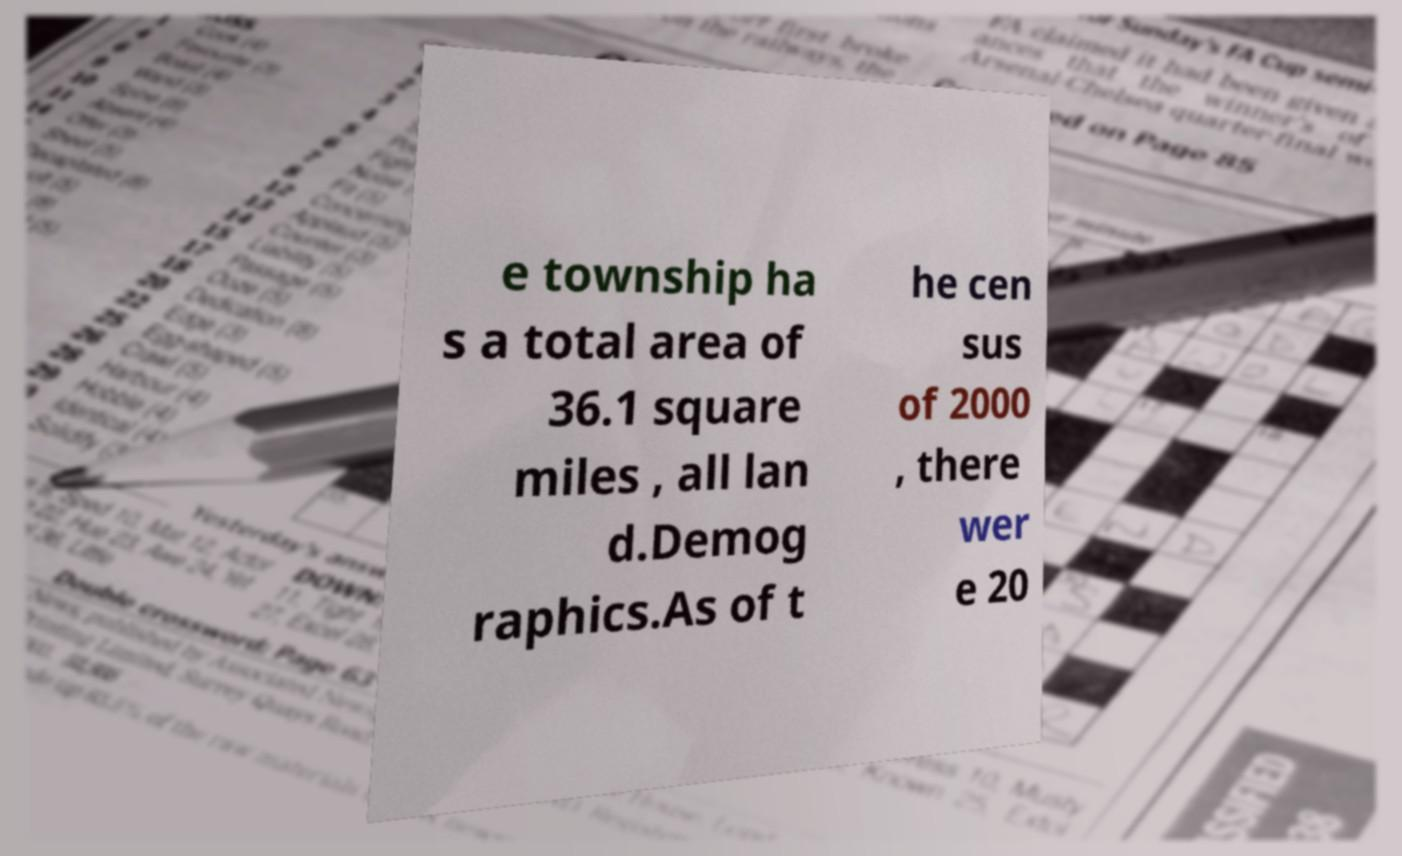I need the written content from this picture converted into text. Can you do that? e township ha s a total area of 36.1 square miles , all lan d.Demog raphics.As of t he cen sus of 2000 , there wer e 20 